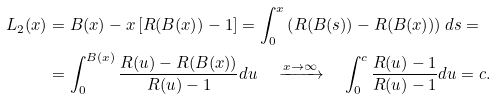<formula> <loc_0><loc_0><loc_500><loc_500>L _ { 2 } ( x ) & = B ( x ) - x \left [ R ( B ( x ) ) - 1 \right ] = \int _ { 0 } ^ { x } \left ( R ( B ( s ) ) - R ( B ( x ) ) \right ) d s = \\ & = \int _ { 0 } ^ { B ( x ) } \frac { R ( u ) - R ( B ( x ) ) } { R ( u ) - 1 } d u \quad \xrightarrow { x \to \infty } \quad \int _ { 0 } ^ { c } \frac { R ( u ) - 1 } { R ( u ) - 1 } d u = c .</formula> 